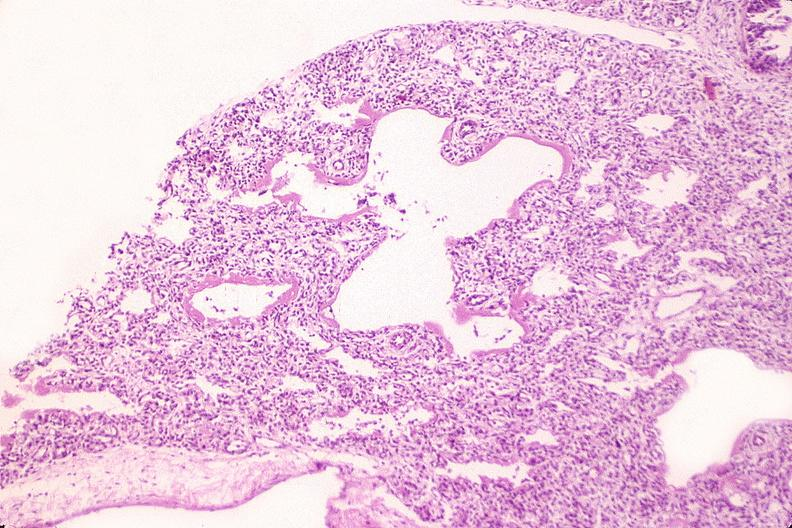where is this?
Answer the question using a single word or phrase. Lung 